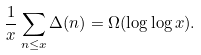Convert formula to latex. <formula><loc_0><loc_0><loc_500><loc_500>\frac { 1 } { x } \sum _ { n \leq x } \Delta ( n ) = \Omega ( \log \log x ) .</formula> 